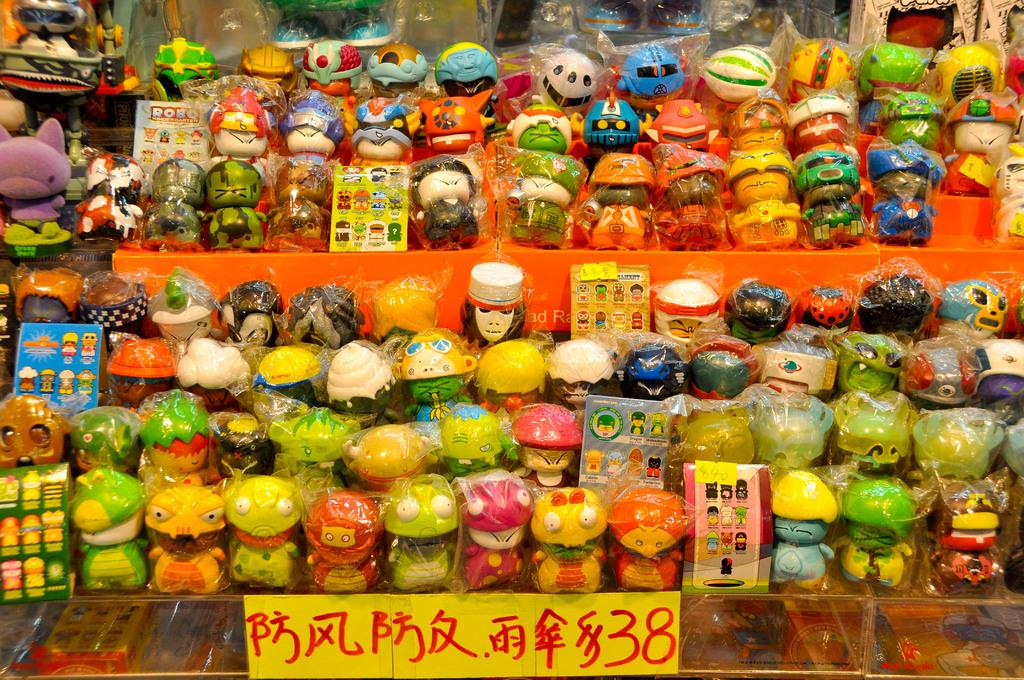<image>
Create a compact narrative representing the image presented. A number of dolls sit on a display rack with a sign in a foreign language ending with 38 below them. 